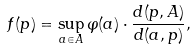<formula> <loc_0><loc_0><loc_500><loc_500>f ( p ) = \sup _ { a \in A } \varphi ( a ) \cdot \frac { d ( p , A ) } { d ( a , p ) } ,</formula> 